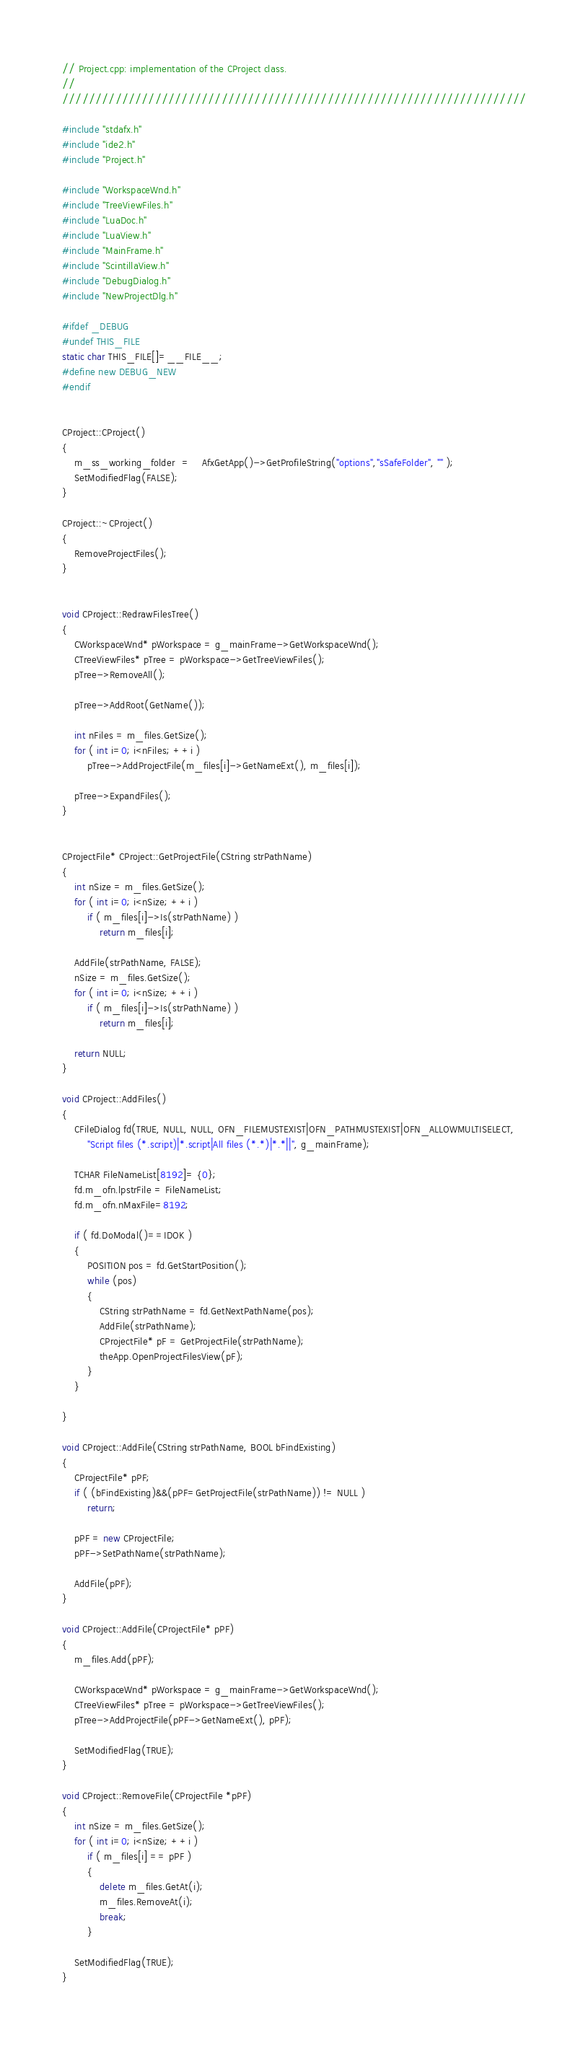Convert code to text. <code><loc_0><loc_0><loc_500><loc_500><_C++_>// Project.cpp: implementation of the CProject class.
//
//////////////////////////////////////////////////////////////////////

#include "stdafx.h"
#include "ide2.h"
#include "Project.h"

#include "WorkspaceWnd.h"
#include "TreeViewFiles.h"
#include "LuaDoc.h"
#include "LuaView.h"
#include "MainFrame.h"
#include "ScintillaView.h"
#include "DebugDialog.h"
#include "NewProjectDlg.h"

#ifdef _DEBUG
#undef THIS_FILE
static char THIS_FILE[]=__FILE__;
#define new DEBUG_NEW
#endif


CProject::CProject()
{
	m_ss_working_folder  = 	AfxGetApp()->GetProfileString("options","sSafeFolder", "" );
	SetModifiedFlag(FALSE);
}

CProject::~CProject()
{
	RemoveProjectFiles();
}


void CProject::RedrawFilesTree()
{
	CWorkspaceWnd* pWorkspace = g_mainFrame->GetWorkspaceWnd();
	CTreeViewFiles* pTree = pWorkspace->GetTreeViewFiles();
	pTree->RemoveAll();

	pTree->AddRoot(GetName());

	int nFiles = m_files.GetSize();
	for ( int i=0; i<nFiles; ++i )
		pTree->AddProjectFile(m_files[i]->GetNameExt(), m_files[i]);

	pTree->ExpandFiles();
}


CProjectFile* CProject::GetProjectFile(CString strPathName)
{
	int nSize = m_files.GetSize();
	for ( int i=0; i<nSize; ++i )
		if ( m_files[i]->Is(strPathName) )
			return m_files[i];

	AddFile(strPathName, FALSE);
	nSize = m_files.GetSize();
	for ( int i=0; i<nSize; ++i )
		if ( m_files[i]->Is(strPathName) )
			return m_files[i];

	return NULL;
}

void CProject::AddFiles()
{
	CFileDialog fd(TRUE, NULL, NULL, OFN_FILEMUSTEXIST|OFN_PATHMUSTEXIST|OFN_ALLOWMULTISELECT, 
		"Script files (*.script)|*.script|All files (*.*)|*.*||", g_mainFrame);

	TCHAR FileNameList[8192]= {0};
	fd.m_ofn.lpstrFile = FileNameList;
	fd.m_ofn.nMaxFile=8192;

	if ( fd.DoModal()==IDOK )
	{
		POSITION pos = fd.GetStartPosition();
		while (pos)
		{
			CString strPathName = fd.GetNextPathName(pos);
			AddFile(strPathName);
			CProjectFile* pF = GetProjectFile(strPathName);
			theApp.OpenProjectFilesView(pF);
		}
	}

}

void CProject::AddFile(CString strPathName, BOOL bFindExisting)
{
 	CProjectFile* pPF;
	if ( (bFindExisting)&&(pPF=GetProjectFile(strPathName)) != NULL )
		return;

	pPF = new CProjectFile;
	pPF->SetPathName(strPathName);

	AddFile(pPF);
}

void CProject::AddFile(CProjectFile* pPF)
{
	m_files.Add(pPF);

	CWorkspaceWnd* pWorkspace = g_mainFrame->GetWorkspaceWnd();
	CTreeViewFiles* pTree = pWorkspace->GetTreeViewFiles();
	pTree->AddProjectFile(pPF->GetNameExt(), pPF);

	SetModifiedFlag(TRUE);
}

void CProject::RemoveFile(CProjectFile *pPF)
{
	int nSize = m_files.GetSize();
	for ( int i=0; i<nSize; ++i )
		if ( m_files[i] == pPF )
		{
			delete m_files.GetAt(i);
			m_files.RemoveAt(i);
			break;
		}

	SetModifiedFlag(TRUE);
}
</code> 